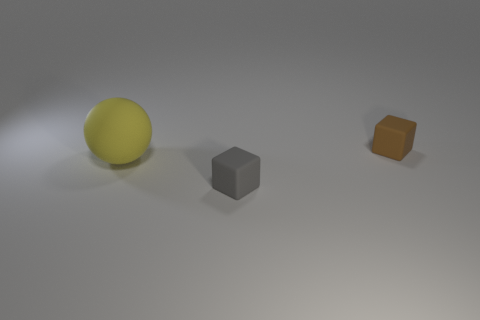Is the number of tiny matte cubes in front of the big yellow rubber sphere less than the number of rubber objects that are on the left side of the small brown thing?
Provide a succinct answer. Yes. What number of other objects are the same size as the yellow rubber object?
Offer a terse response. 0. Are the large ball and the block behind the gray matte cube made of the same material?
Your answer should be very brief. Yes. How many objects are things in front of the small brown matte thing or matte objects to the left of the tiny brown rubber cube?
Keep it short and to the point. 2. What is the color of the large matte thing?
Your answer should be very brief. Yellow. Is the number of tiny brown matte things that are behind the small brown rubber block less than the number of red rubber cylinders?
Ensure brevity in your answer.  No. Is there anything else that is the same shape as the big yellow thing?
Your answer should be very brief. No. Are any small yellow matte blocks visible?
Keep it short and to the point. No. Is the number of yellow matte objects less than the number of blue rubber objects?
Provide a succinct answer. No. How many tiny gray objects have the same material as the sphere?
Make the answer very short. 1. 